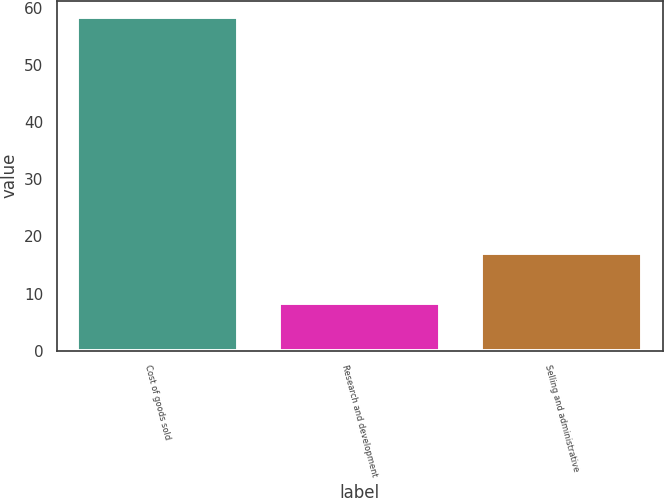Convert chart. <chart><loc_0><loc_0><loc_500><loc_500><bar_chart><fcel>Cost of goods sold<fcel>Research and development<fcel>Selling and administrative<nl><fcel>58.3<fcel>8.3<fcel>17.1<nl></chart> 